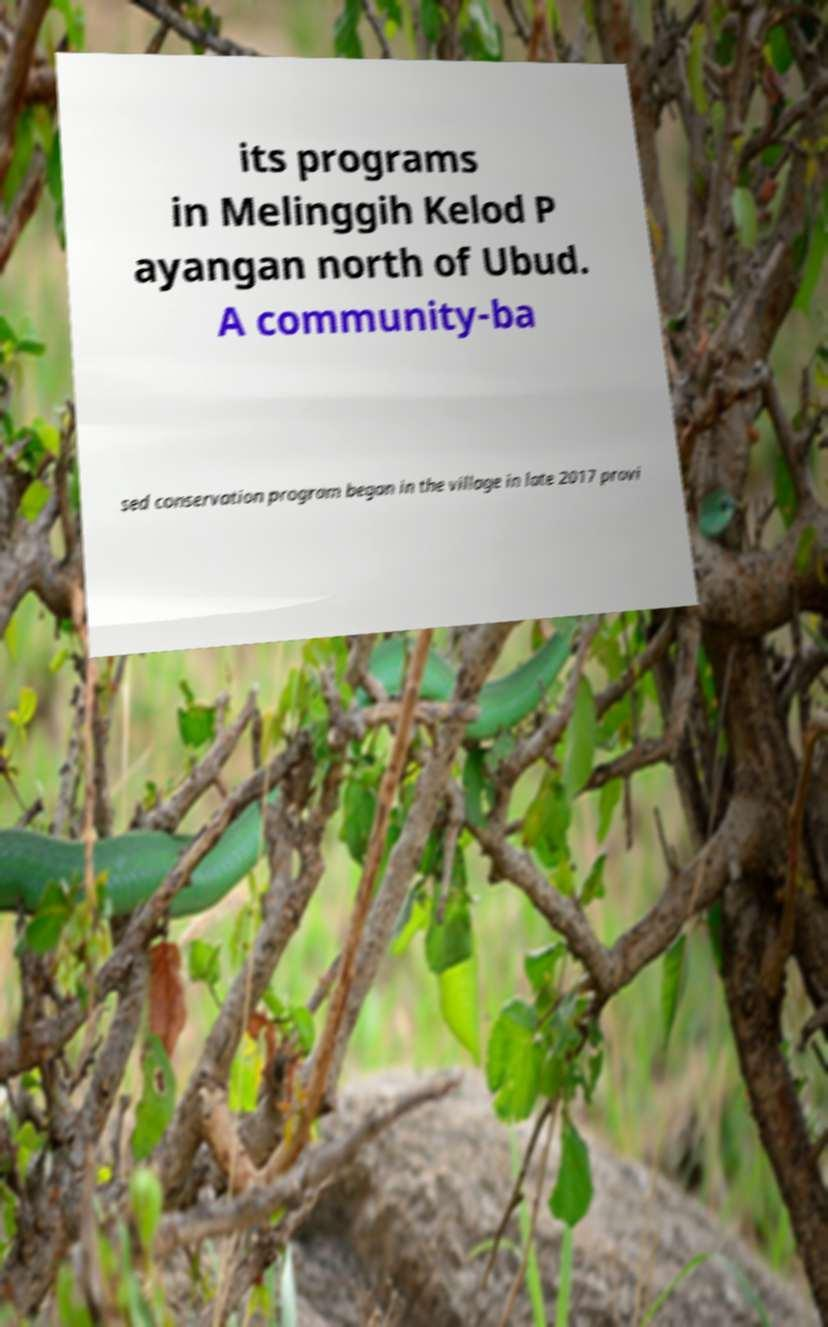Could you extract and type out the text from this image? its programs in Melinggih Kelod P ayangan north of Ubud. A community-ba sed conservation program began in the village in late 2017 provi 